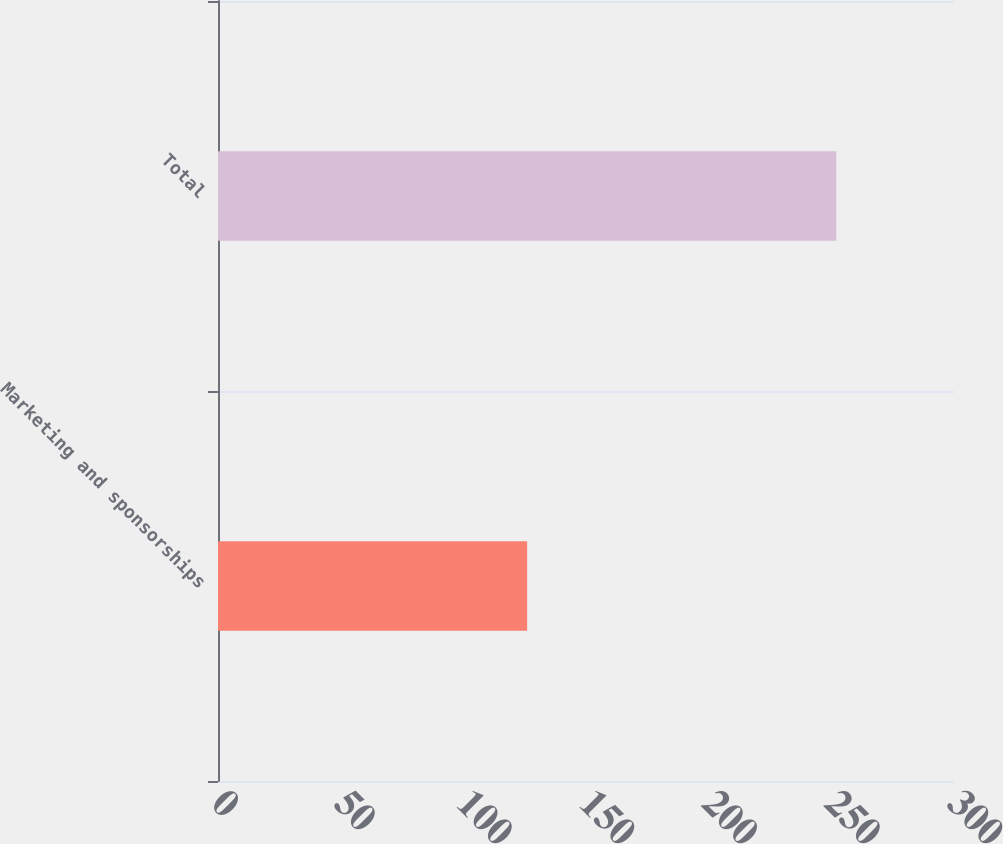<chart> <loc_0><loc_0><loc_500><loc_500><bar_chart><fcel>Marketing and sponsorships<fcel>Total<nl><fcel>126<fcel>252<nl></chart> 